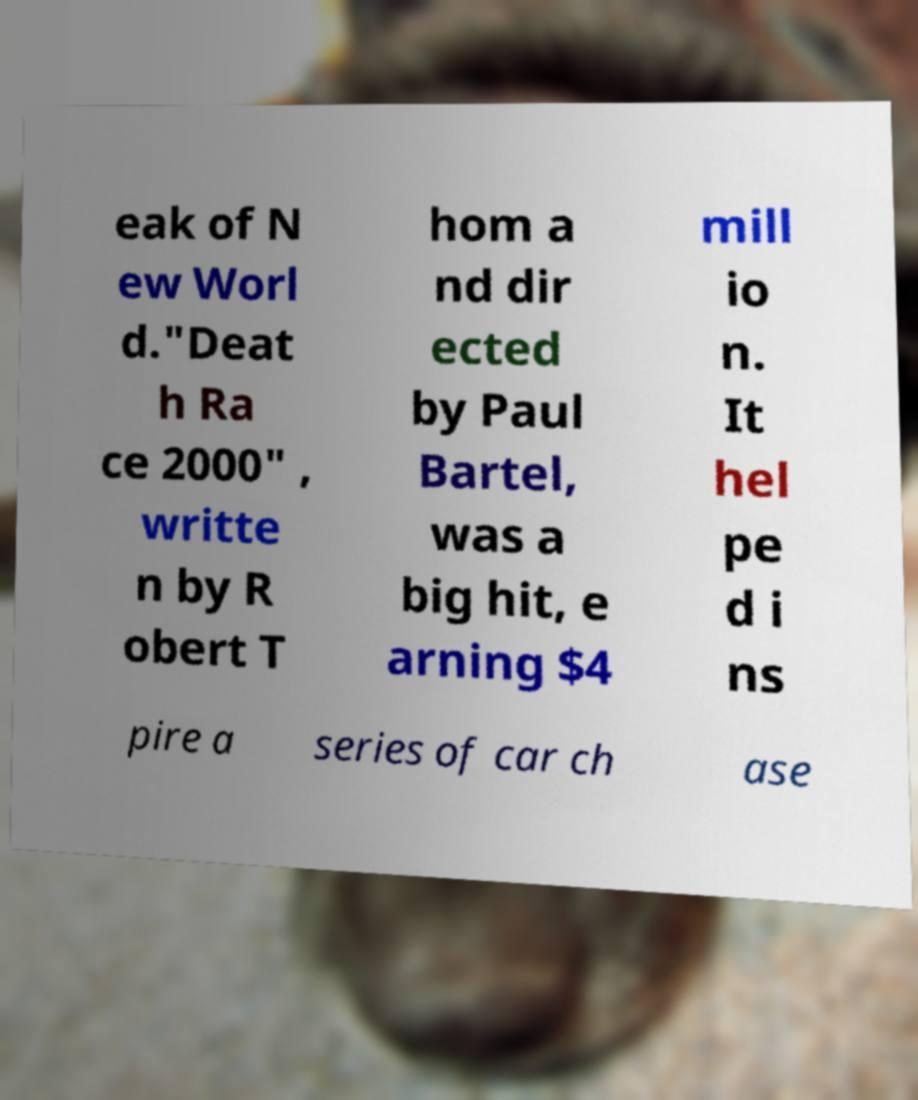Can you accurately transcribe the text from the provided image for me? eak of N ew Worl d."Deat h Ra ce 2000" , writte n by R obert T hom a nd dir ected by Paul Bartel, was a big hit, e arning $4 mill io n. It hel pe d i ns pire a series of car ch ase 